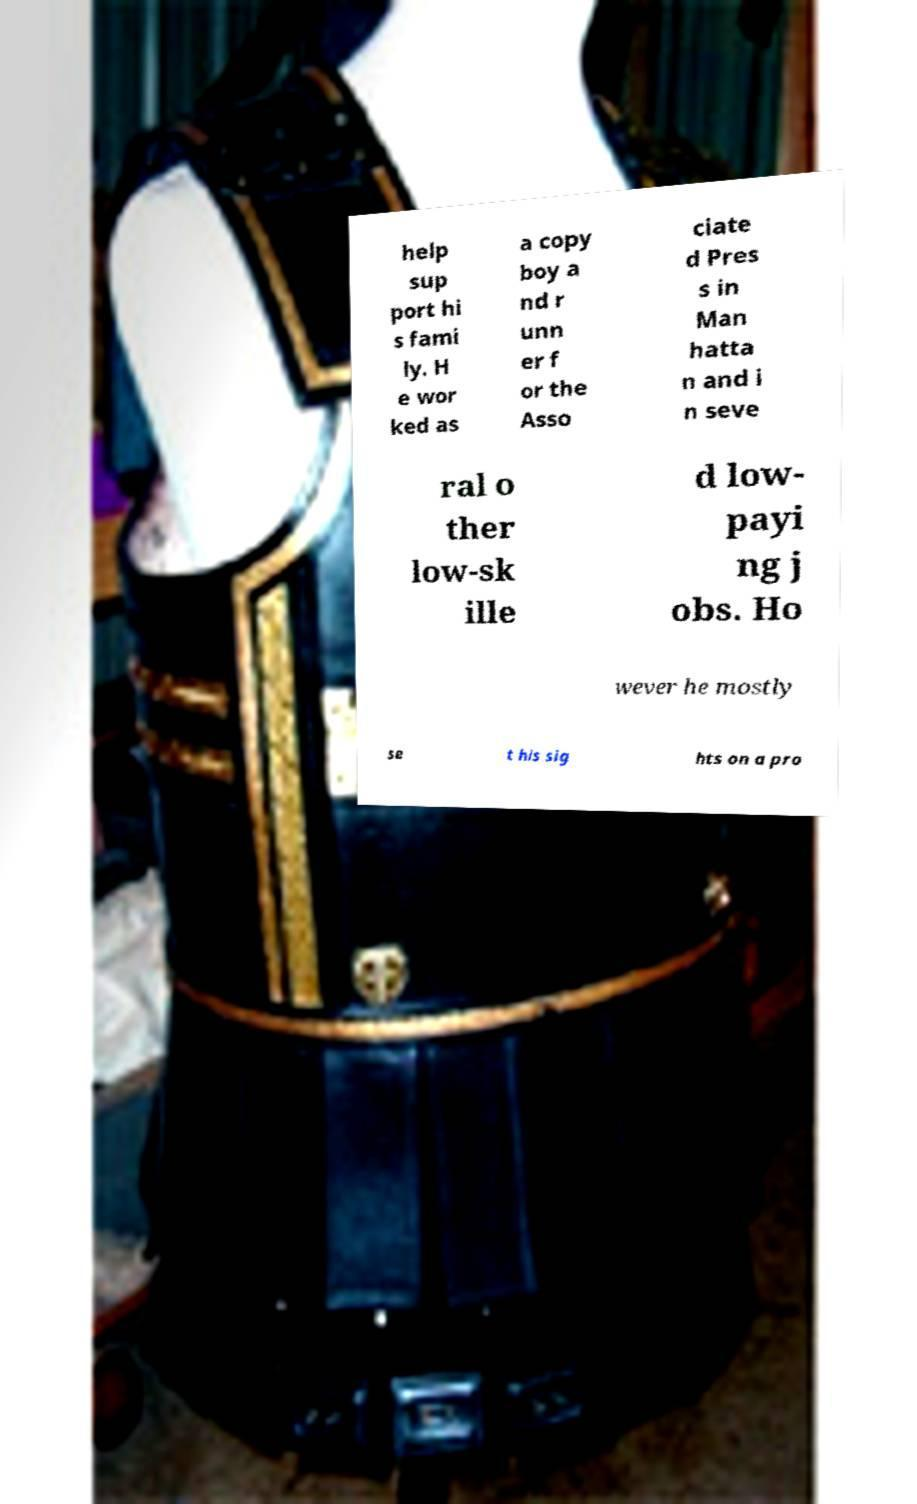Please identify and transcribe the text found in this image. help sup port hi s fami ly. H e wor ked as a copy boy a nd r unn er f or the Asso ciate d Pres s in Man hatta n and i n seve ral o ther low-sk ille d low- payi ng j obs. Ho wever he mostly se t his sig hts on a pro 